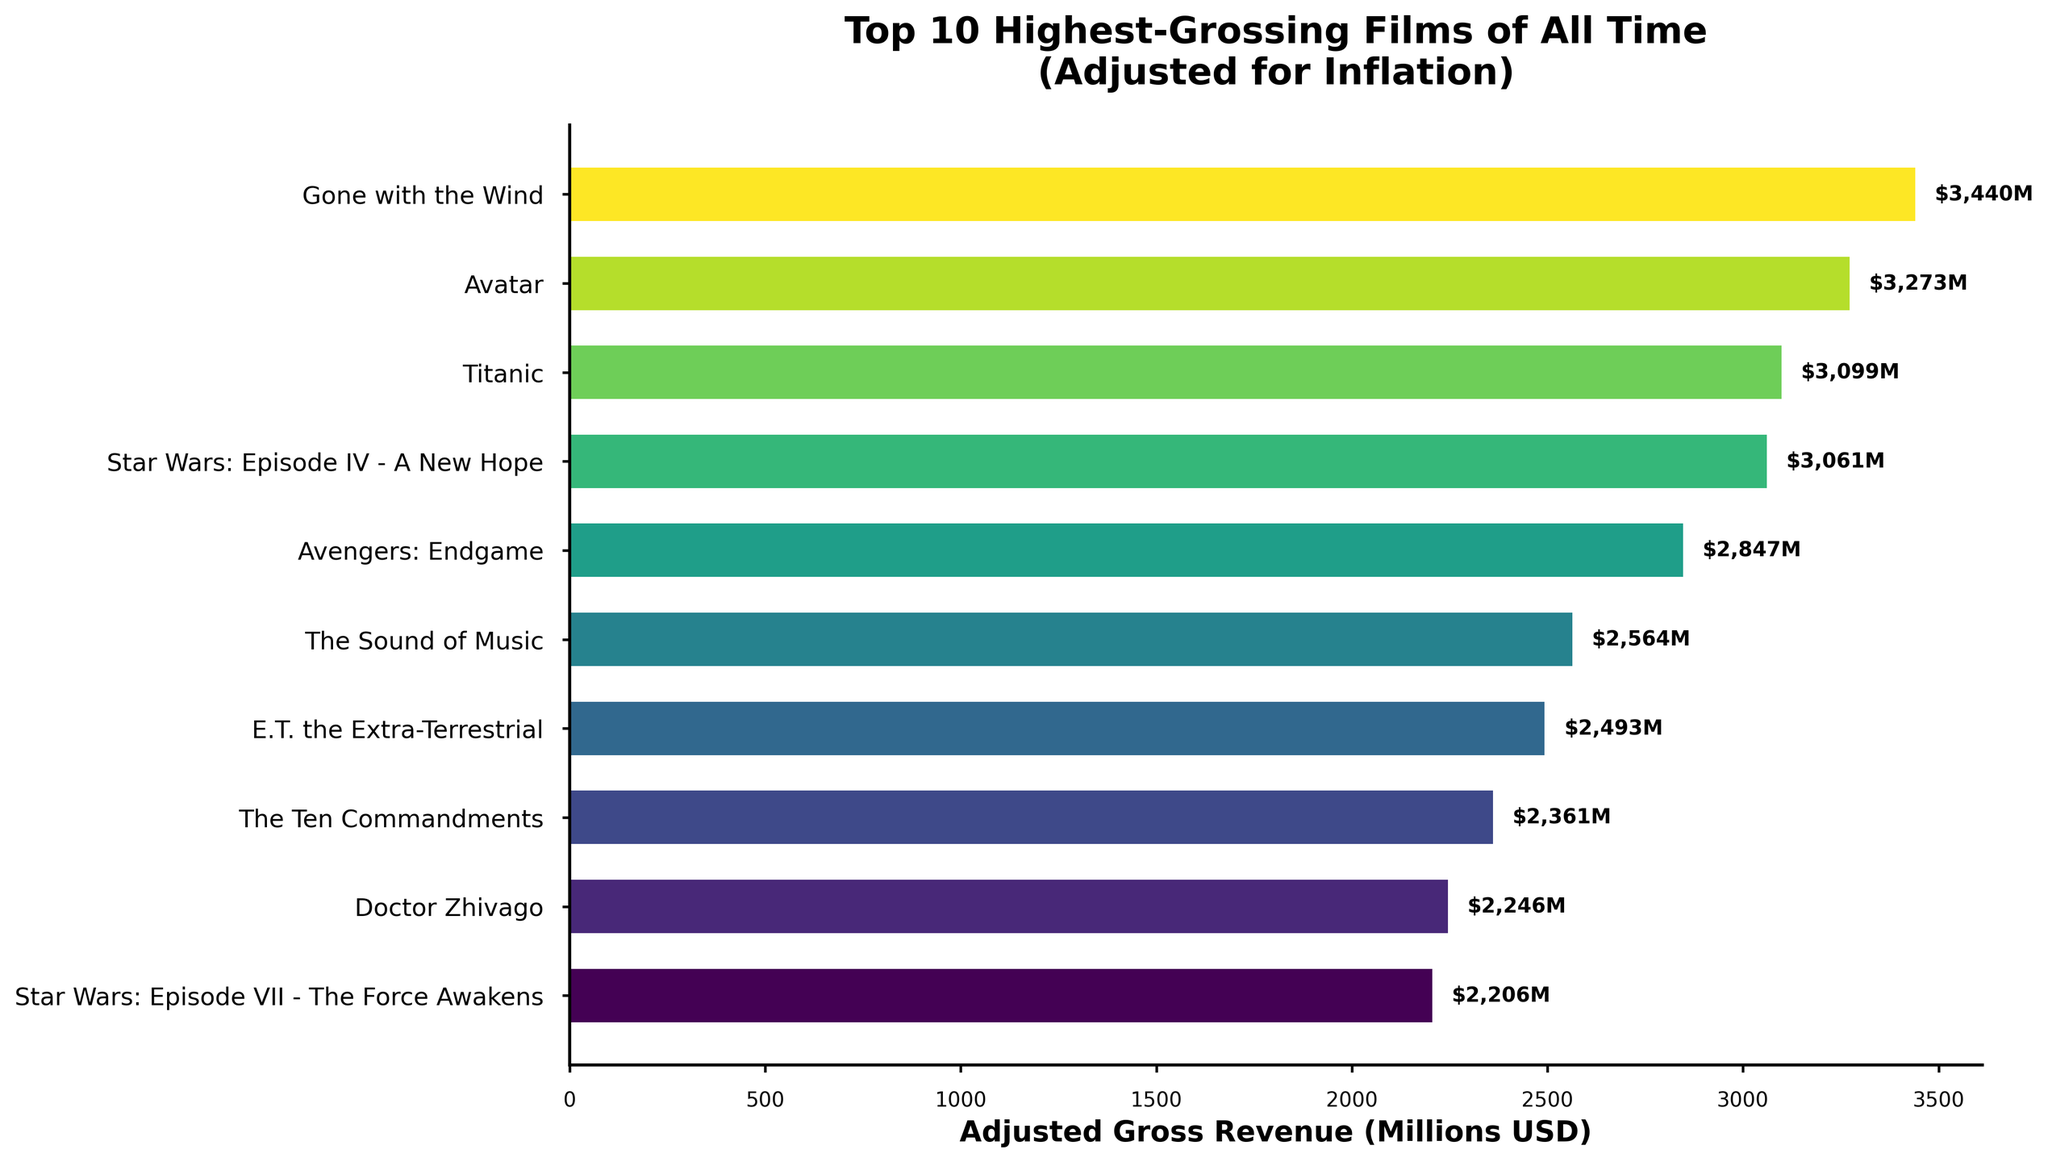Which film has the highest adjusted gross revenue? The bar for "Gone with the Wind" extends the furthest to the right, indicating the highest adjusted gross revenue.
Answer: Gone with the Wind What is the difference in adjusted gross revenue between "Avatar" and "Star Wars: Episode IV - A New Hope"? "Avatar" has an adjusted gross revenue of 3273 million USD, while "Star Wars: Episode IV - A New Hope" has 3061 million USD. The difference is 3273 - 3061 = 212 million USD.
Answer: 212 million USD Which film in the list has the smallest adjusted gross revenue? The shortest bar represents "Star Wars: Episode VII - The Force Awakens" with an adjusted gross revenue of 2206 million USD.
Answer: Star Wars: Episode VII - The Force Awakens List the films with adjusted gross revenues greater than 3000 million USD. From the bars, the films with adjusted gross revenues greater than 3000 million USD are "Gone with the Wind," "Avatar," "Titanic," and "Star Wars: Episode IV - A New Hope."
Answer: Gone with the Wind, Avatar, Titanic, Star Wars: Episode IV - A New Hope What is the combined adjusted gross revenue of "The Ten Commandments" and "Doctor Zhivago"? "The Ten Commandments" has an adjusted gross revenue of 2361 million USD, and "Doctor Zhivago" has 2246 million USD. The combined revenue is 2361 + 2246 = 4607 million USD.
Answer: 4607 million USD How much more adjusted gross revenue does "Titanic" have compared to "Avengers: Endgame"? "Titanic" has 3099 million USD, and "Avengers: Endgame" has 2847 million USD. The difference is 3099 - 2847 = 252 million USD.
Answer: 252 million USD What is the average adjusted gross revenue of the top three films? The adjusted gross revenues for the top three films are 3440 (Gone with the Wind), 3273 (Avatar), and 3099 (Titanic). The sum is 3440 + 3273 + 3099 = 9812 million USD. The average is 9812/3 = 3270.67 million USD.
Answer: 3270.67 million USD Between "E.T. the Extra-Terrestrial" and "The Sound of Music," which has a higher adjusted gross revenue? "The Sound of Music" has 2564 million USD, while "E.T. the Extra-Terrestrial" has 2493 million USD.
Answer: The Sound of Music What percentage of "Gone with the Wind’s" adjusted gross revenue is "Star Wars: Episode VII - The Force Awakens" adjusted gross revenue? "Gone with the Wind" has 3440 million USD, and "Star Wars: Episode VII - The Force Awakens" has 2206 million USD. The percentage is (2206 / 3440) * 100 ≈ 64.14%.
Answer: 64.14% 